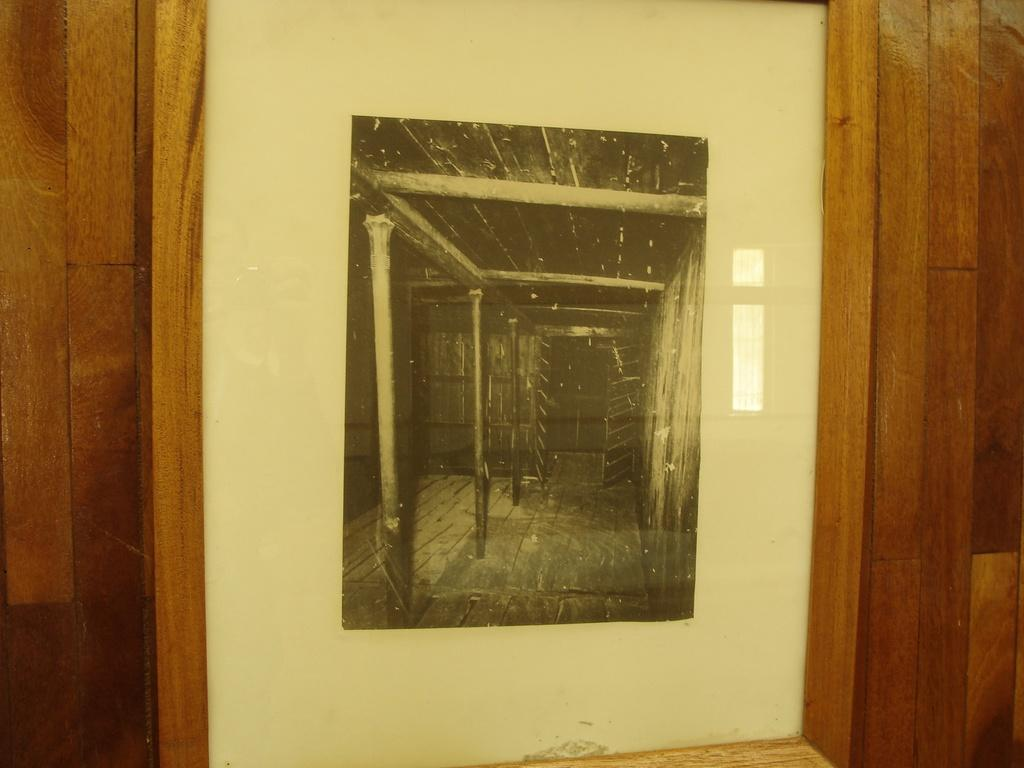What is on the wall in the image? There is a frame on the wall in the image. What material is the frame made of? The frame is made of wood. What type of amusement can be seen in the image? There is no amusement present in the image; it only features a wooden frame on the wall. Is there a flame visible in the image? No, there is no flame present in the image. 